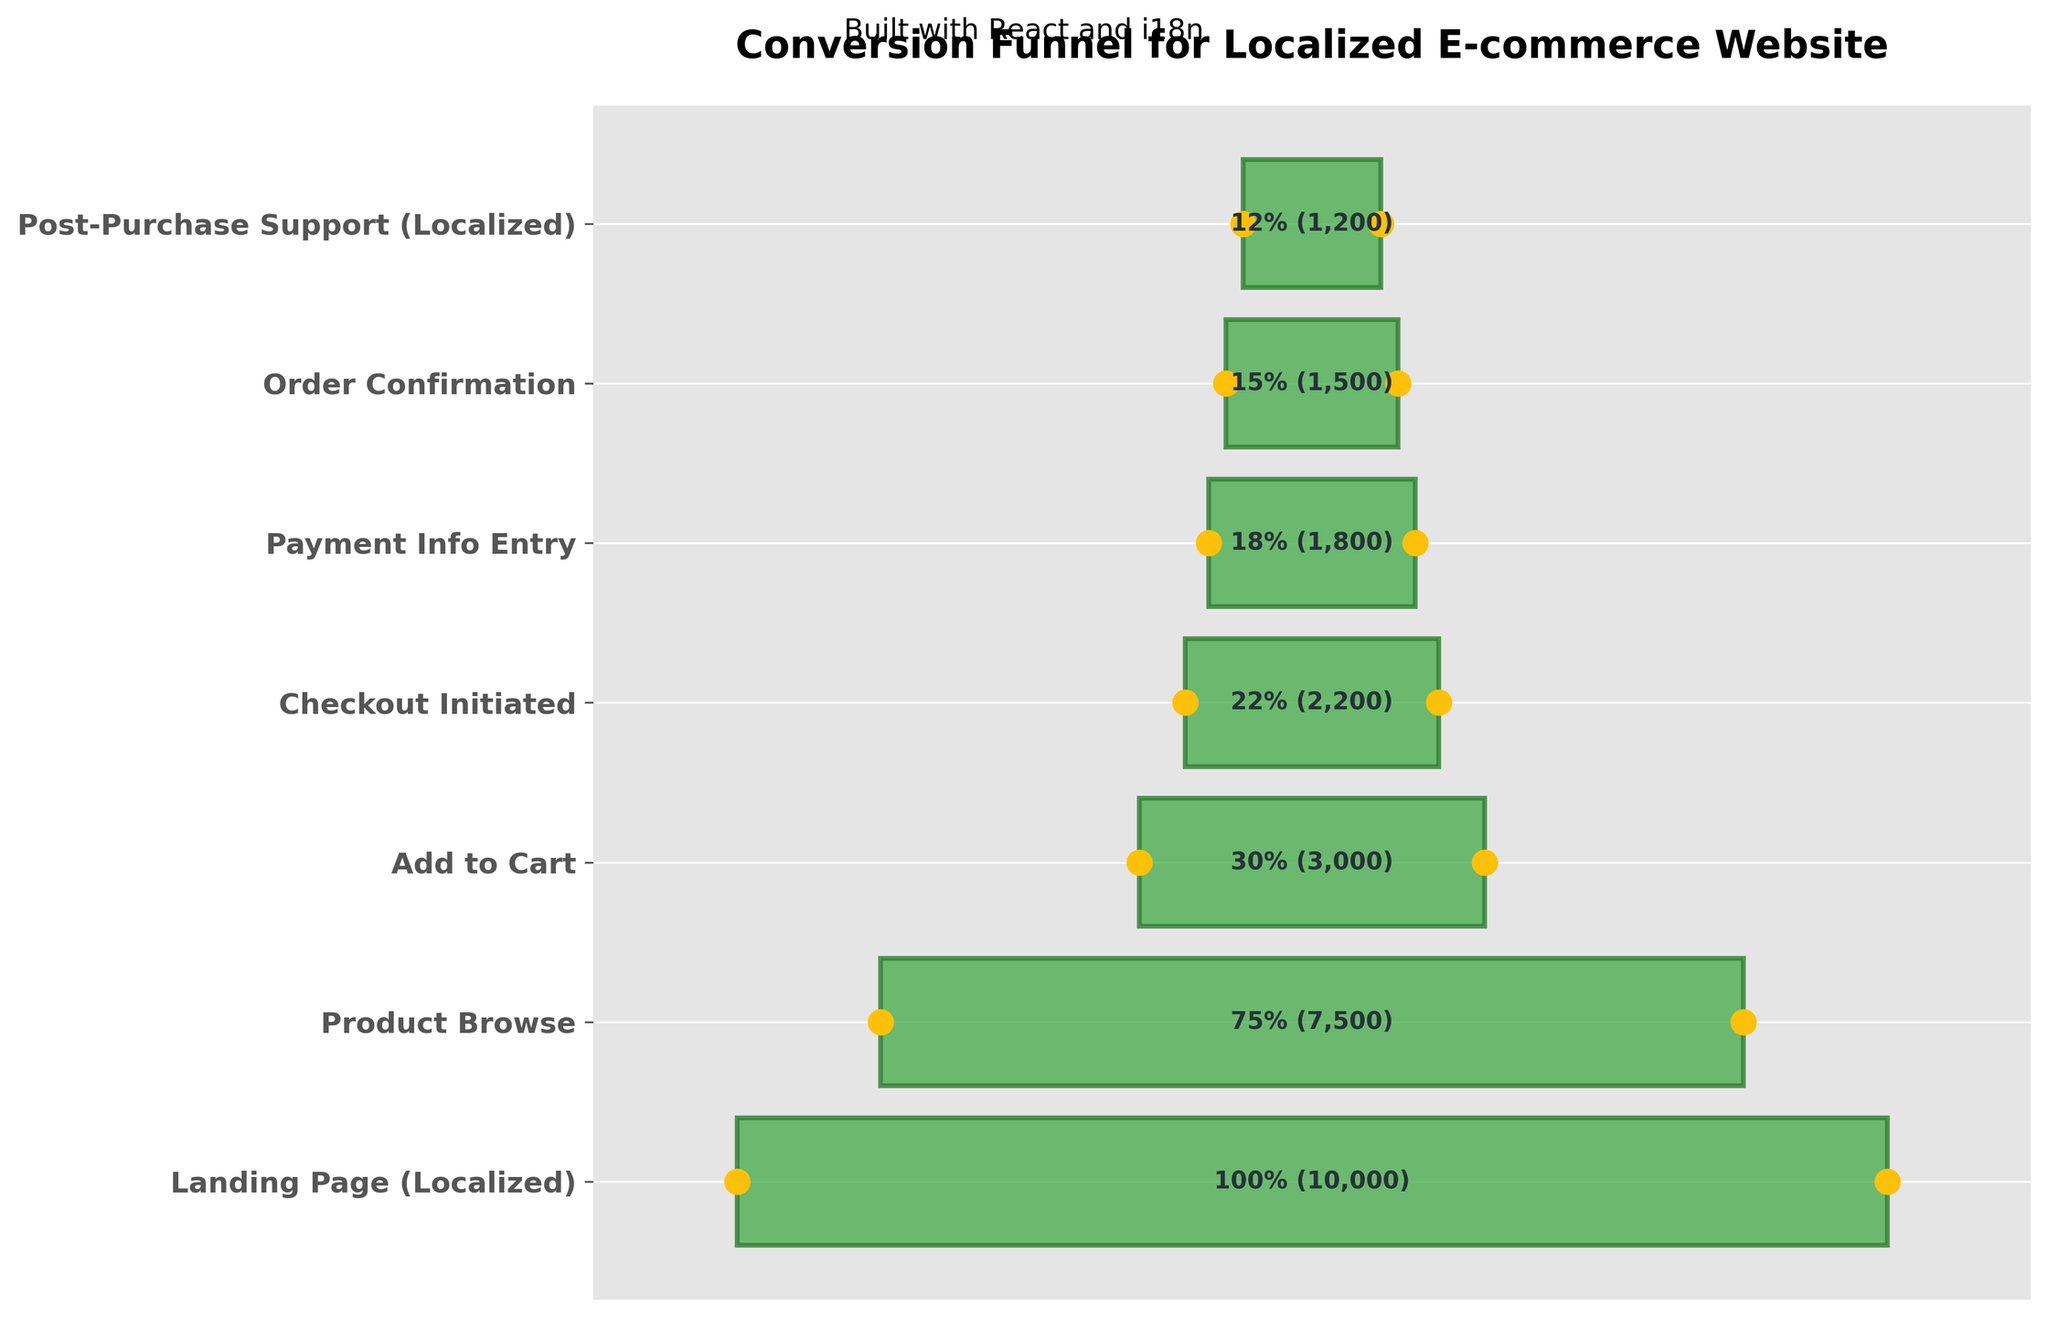How many stages are represented in the funnel chart? There are 7 stages listed in the funnel chart: "Landing Page (Localized)," "Product Browse," "Add to Cart," "Checkout Initiated," "Payment Info Entry," "Order Confirmation," and "Post-Purchase Support (Localized)."
Answer: 7 What percentage of users who landed on the page proceeded to the 'Checkout Initiated' stage? To find this, look at the percentage for the 'Checkout Initiated' stage, which is 22%.
Answer: 22% What is the difference in the number of users between the 'Add to Cart' stage and the 'Post-Purchase Support (Localized)' stage? The 'Add to Cart' stage has 3000 users, and the 'Post-Purchase Support (Localized)' stage has 1200 users. The difference is 3000 - 1200 = 1800.
Answer: 1800 Which stage has the lowest number of users? The 'Post-Purchase Support (Localized)' stage has the lowest number of users, with 1200 users.
Answer: Post-Purchase Support (Localized) How many users left the funnel between 'Product Browse' and 'Add to Cart'? 'Product Browse' has 7500 users, and 'Add to Cart' has 3000 users. The number of users who left the funnel between these stages is 7500 - 3000 = 4500.
Answer: 4500 What stage follows directly after 'Payment Info Entry'? The stage that follows directly after 'Payment Info Entry' is 'Order Confirmation.'
Answer: Order Confirmation What is the cumulative drop-off percentage from the 'Landing Page' to 'Order Confirmation'? The 'Order Confirmation' stage has 15% of users compared to the 'Landing Page,' which has 100%. The drop-off percentage is 100% - 15% = 85%.
Answer: 85% Which two stages have the largest percentage drop between them? The stages 'Product Browse' (75%) and 'Add to Cart' (30%) have the largest drop, with a difference of 75% - 30% = 45%.
Answer: Product Browse and Add to Cart How many users move from 'Payment Info Entry' to 'Post-Purchase Support (Localized)'? 'Payment Info Entry' has 1800 users, and 'Post-Purchase Support (Localized)' has 1200 users. The number of users moving to the next stage is 1200, meaning 600 users do not proceed.
Answer: 1200 By what percentage do users decrease from 'Checkout Initiated' to 'Order Confirmation'? 'Checkout Initiated' has 2200 users, and 'Order Confirmation' has 1500 users. The percentage decrease is calculated by (2200 - 1500) / 2200 * 100% = 31.82%.
Answer: 31.82% 